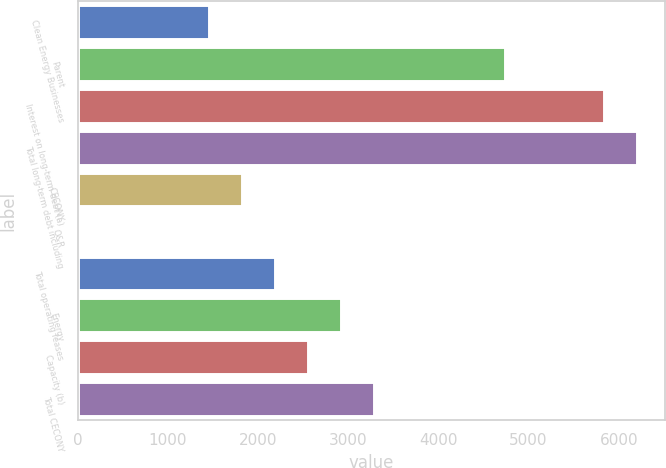Convert chart. <chart><loc_0><loc_0><loc_500><loc_500><bar_chart><fcel>Clean Energy Businesses<fcel>Parent<fcel>Interest on long-term debt (a)<fcel>Total long-term debt including<fcel>CECONY<fcel>O&R<fcel>Total operating leases<fcel>Energy<fcel>Capacity (b)<fcel>Total CECONY<nl><fcel>1459<fcel>4739.5<fcel>5833<fcel>6197.5<fcel>1823.5<fcel>1<fcel>2188<fcel>2917<fcel>2552.5<fcel>3281.5<nl></chart> 